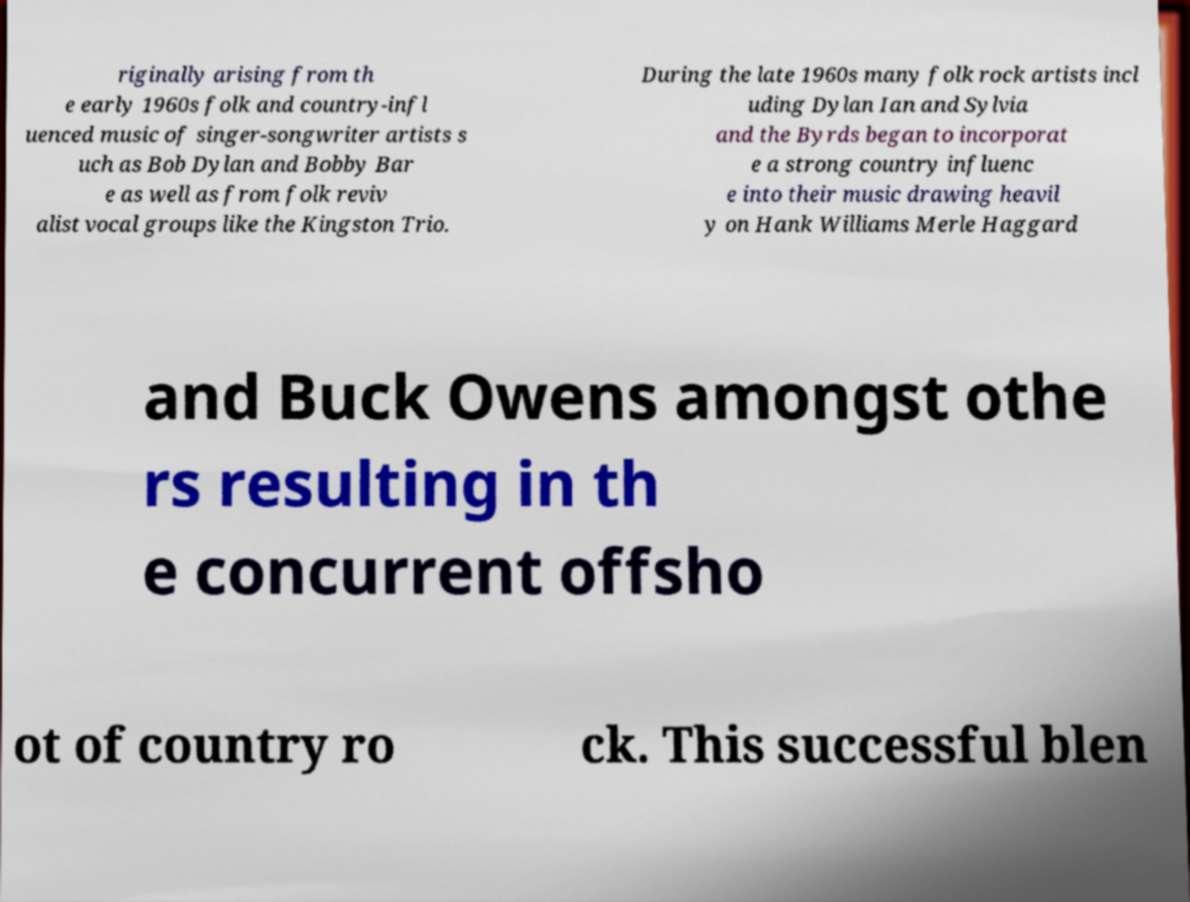Please read and relay the text visible in this image. What does it say? riginally arising from th e early 1960s folk and country-infl uenced music of singer-songwriter artists s uch as Bob Dylan and Bobby Bar e as well as from folk reviv alist vocal groups like the Kingston Trio. During the late 1960s many folk rock artists incl uding Dylan Ian and Sylvia and the Byrds began to incorporat e a strong country influenc e into their music drawing heavil y on Hank Williams Merle Haggard and Buck Owens amongst othe rs resulting in th e concurrent offsho ot of country ro ck. This successful blen 